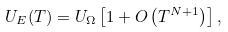<formula> <loc_0><loc_0><loc_500><loc_500>U _ { E } ( T ) = U _ { \Omega } \left [ 1 + O \left ( T ^ { N + 1 } \right ) \right ] ,</formula> 